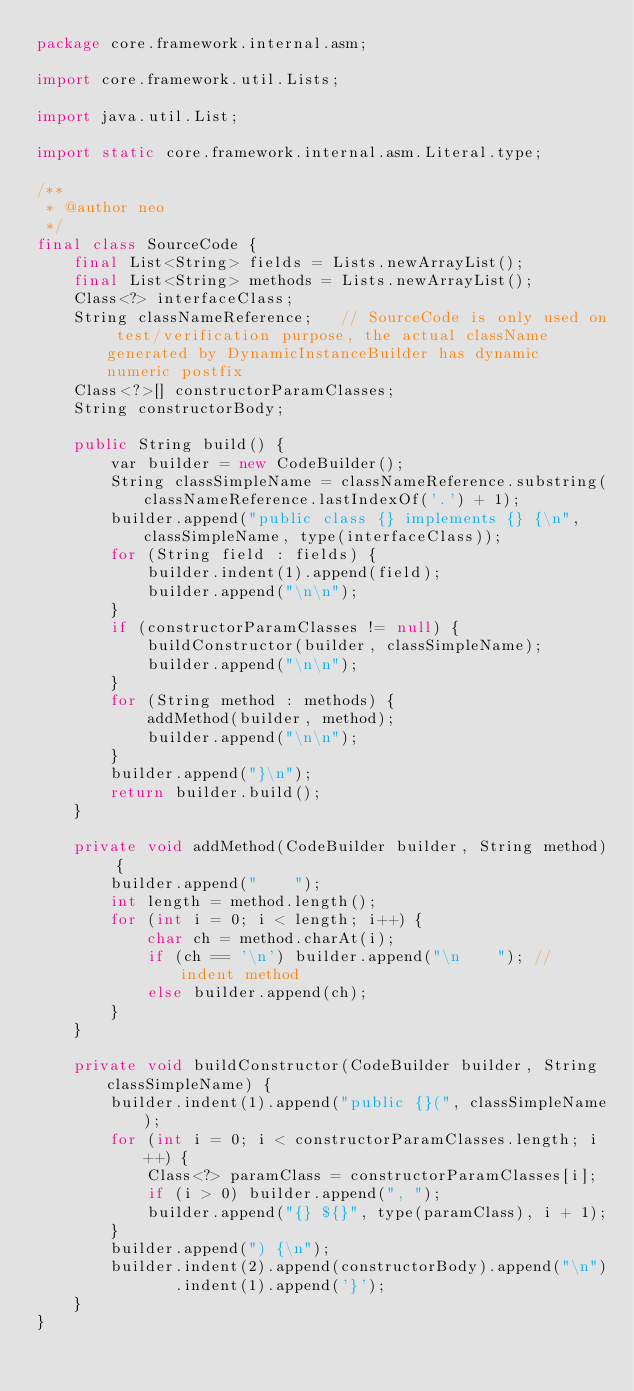<code> <loc_0><loc_0><loc_500><loc_500><_Java_>package core.framework.internal.asm;

import core.framework.util.Lists;

import java.util.List;

import static core.framework.internal.asm.Literal.type;

/**
 * @author neo
 */
final class SourceCode {
    final List<String> fields = Lists.newArrayList();
    final List<String> methods = Lists.newArrayList();
    Class<?> interfaceClass;
    String classNameReference;   // SourceCode is only used on test/verification purpose, the actual className generated by DynamicInstanceBuilder has dynamic numeric postfix
    Class<?>[] constructorParamClasses;
    String constructorBody;

    public String build() {
        var builder = new CodeBuilder();
        String classSimpleName = classNameReference.substring(classNameReference.lastIndexOf('.') + 1);
        builder.append("public class {} implements {} {\n", classSimpleName, type(interfaceClass));
        for (String field : fields) {
            builder.indent(1).append(field);
            builder.append("\n\n");
        }
        if (constructorParamClasses != null) {
            buildConstructor(builder, classSimpleName);
            builder.append("\n\n");
        }
        for (String method : methods) {
            addMethod(builder, method);
            builder.append("\n\n");
        }
        builder.append("}\n");
        return builder.build();
    }

    private void addMethod(CodeBuilder builder, String method) {
        builder.append("    ");
        int length = method.length();
        for (int i = 0; i < length; i++) {
            char ch = method.charAt(i);
            if (ch == '\n') builder.append("\n    "); // indent method
            else builder.append(ch);
        }
    }

    private void buildConstructor(CodeBuilder builder, String classSimpleName) {
        builder.indent(1).append("public {}(", classSimpleName);
        for (int i = 0; i < constructorParamClasses.length; i++) {
            Class<?> paramClass = constructorParamClasses[i];
            if (i > 0) builder.append(", ");
            builder.append("{} ${}", type(paramClass), i + 1);
        }
        builder.append(") {\n");
        builder.indent(2).append(constructorBody).append("\n")
               .indent(1).append('}');
    }
}
</code> 